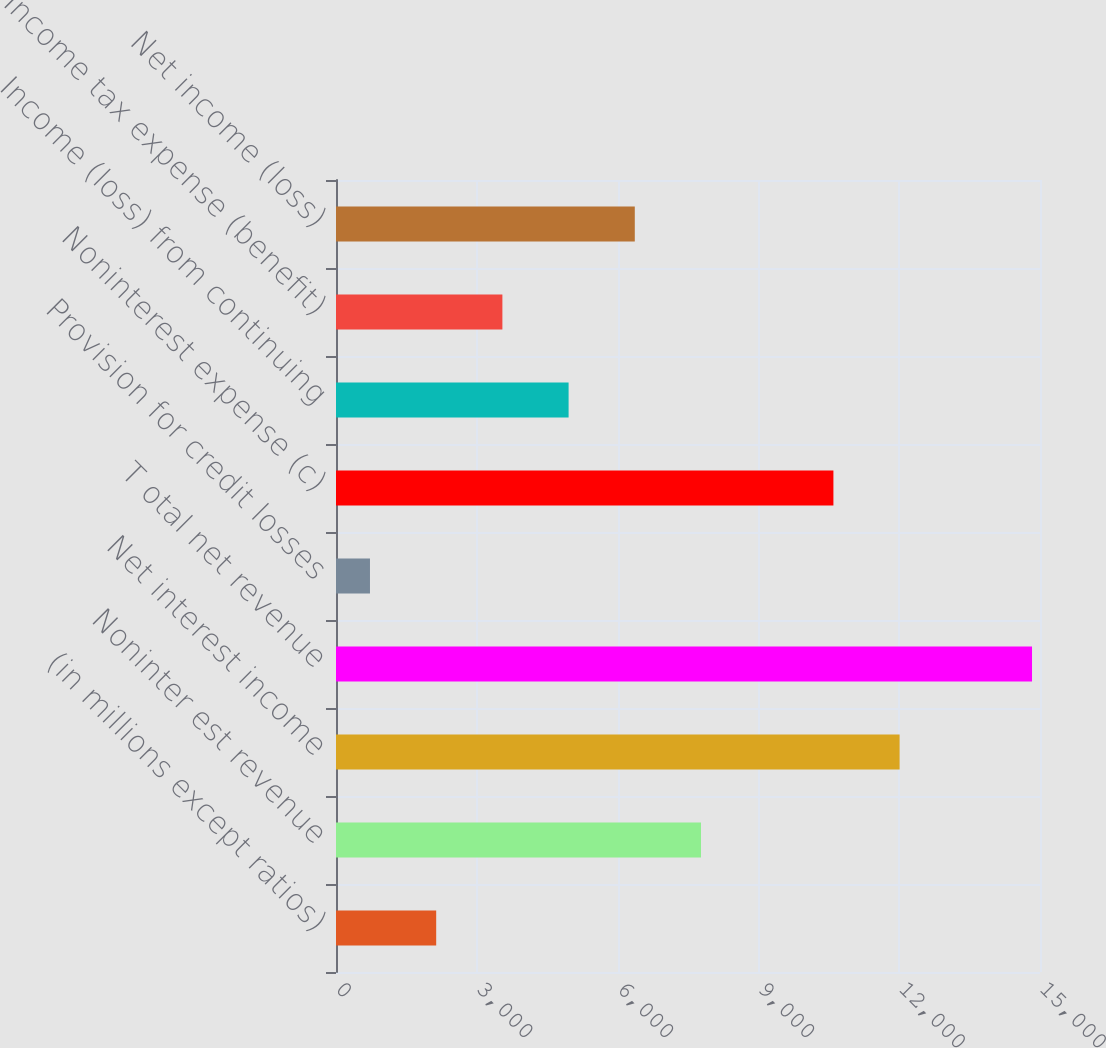Convert chart. <chart><loc_0><loc_0><loc_500><loc_500><bar_chart><fcel>(in millions except ratios)<fcel>Noninter est revenue<fcel>Net interest income<fcel>T otal net revenue<fcel>Provision for credit losses<fcel>Noninterest expense (c)<fcel>Income (loss) from continuing<fcel>Income tax expense (benefit)<fcel>Net income (loss)<nl><fcel>2134.6<fcel>7777<fcel>12008.8<fcel>14830<fcel>724<fcel>10598.2<fcel>4955.8<fcel>3545.2<fcel>6366.4<nl></chart> 